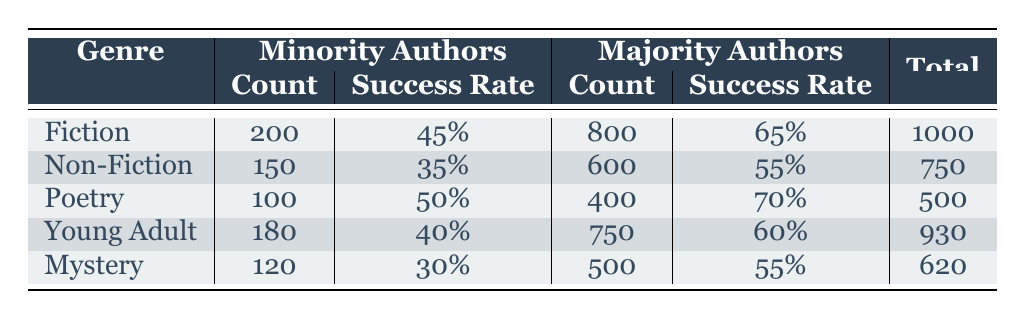What is the success rate for Fiction by Minority Authors? The table shows that the success rate for Fiction by Minority Authors is 45%.
Answer: 45% How many total authors are represented in the Young Adult genre? To find the total authors in the Young Adult genre, we add the count of Minority Authors (180) and Majority Authors (750). So, 180 + 750 = 930.
Answer: 930 Which genre has the highest success rate for Majority Authors? Looking through the table, we see that Poetry has the highest success rate for Majority Authors at 70%.
Answer: 70% Is the success rate for Non-Fiction by Minority Authors higher than that for Mystery by Minority Authors? The success rate for Non-Fiction by Minority Authors is 35%, while for Mystery it's 30%. Since 35% is greater than 30%, the statement is true.
Answer: Yes What is the average success rate for Minority Authors across all genres? We calculate the average by adding the success rates for Minority Authors: (45% + 35% + 50% + 40% + 30%) / 5 = 200% / 5 = 40%.
Answer: 40% In how many genres does the representation of Majority Authors exceed 60% success rate? The success rates for Majority Authors are 65% (Fiction), 55% (Non-Fiction), 70% (Poetry), 60% (Young Adult), and 55% (Mystery). Only Fiction and Poetry exceed 60%, thus there are 2 genres.
Answer: 2 What is the total count of books written by Minority Authors across all genres? Adding the counts of Minority Authors: 200 (Fiction) + 150 (Non-Fiction) + 100 (Poetry) + 180 (Young Adult) + 120 (Mystery) results in a total of 850.
Answer: 850 Does the Mystery genre have a higher count of Majority Authors than the Poetry genre? The count of Majority Authors for Mystery is 500, and for Poetry, it is 400. Since 500 is greater than 400, the statement is true.
Answer: Yes What is the success rate difference between Majority Authors in Fiction and Young Adult? The difference is calculated by subtracting the success rate for Young Adult (60%) from that of Fiction (65%): 65% - 60% = 5%.
Answer: 5% 